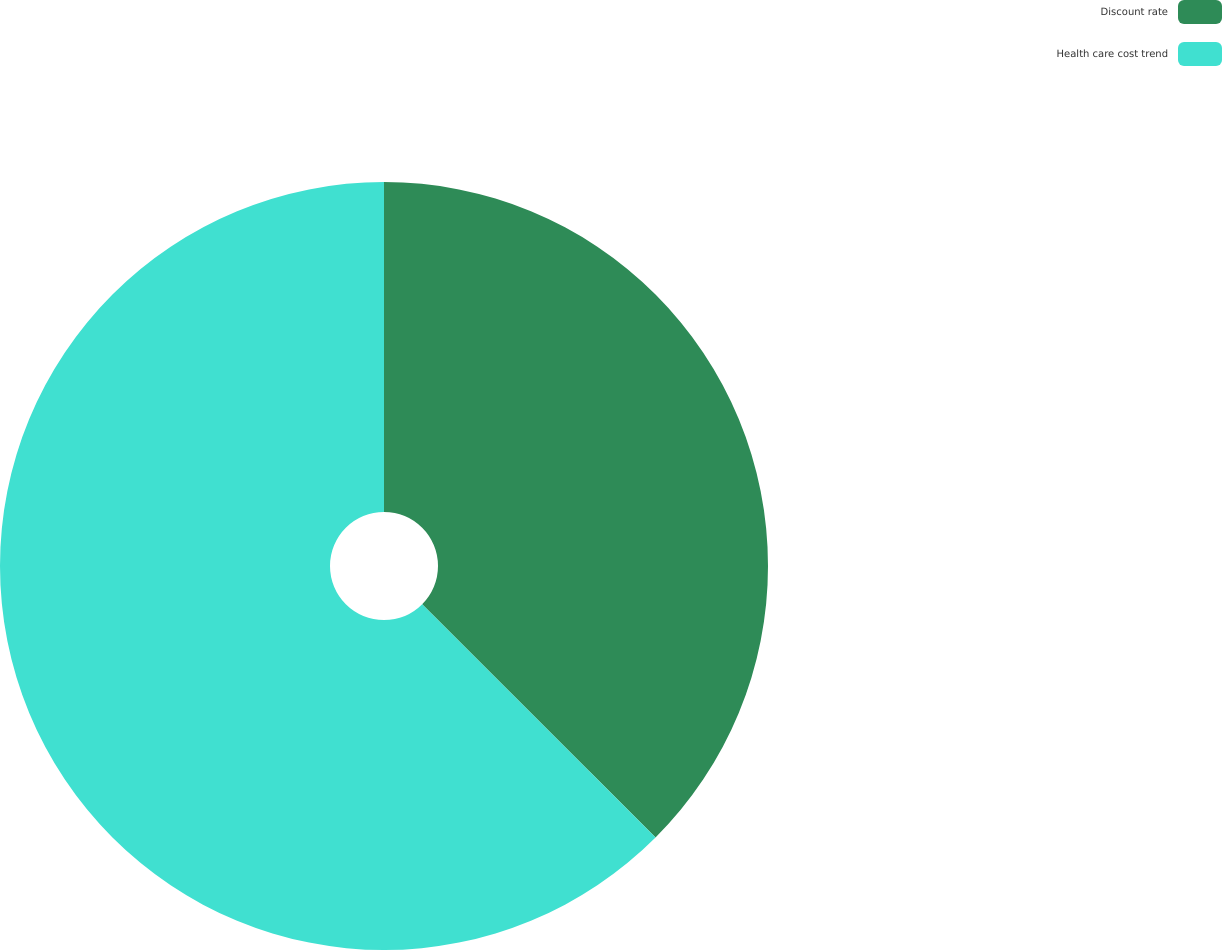Convert chart. <chart><loc_0><loc_0><loc_500><loc_500><pie_chart><fcel>Discount rate<fcel>Health care cost trend<nl><fcel>37.5%<fcel>62.5%<nl></chart> 